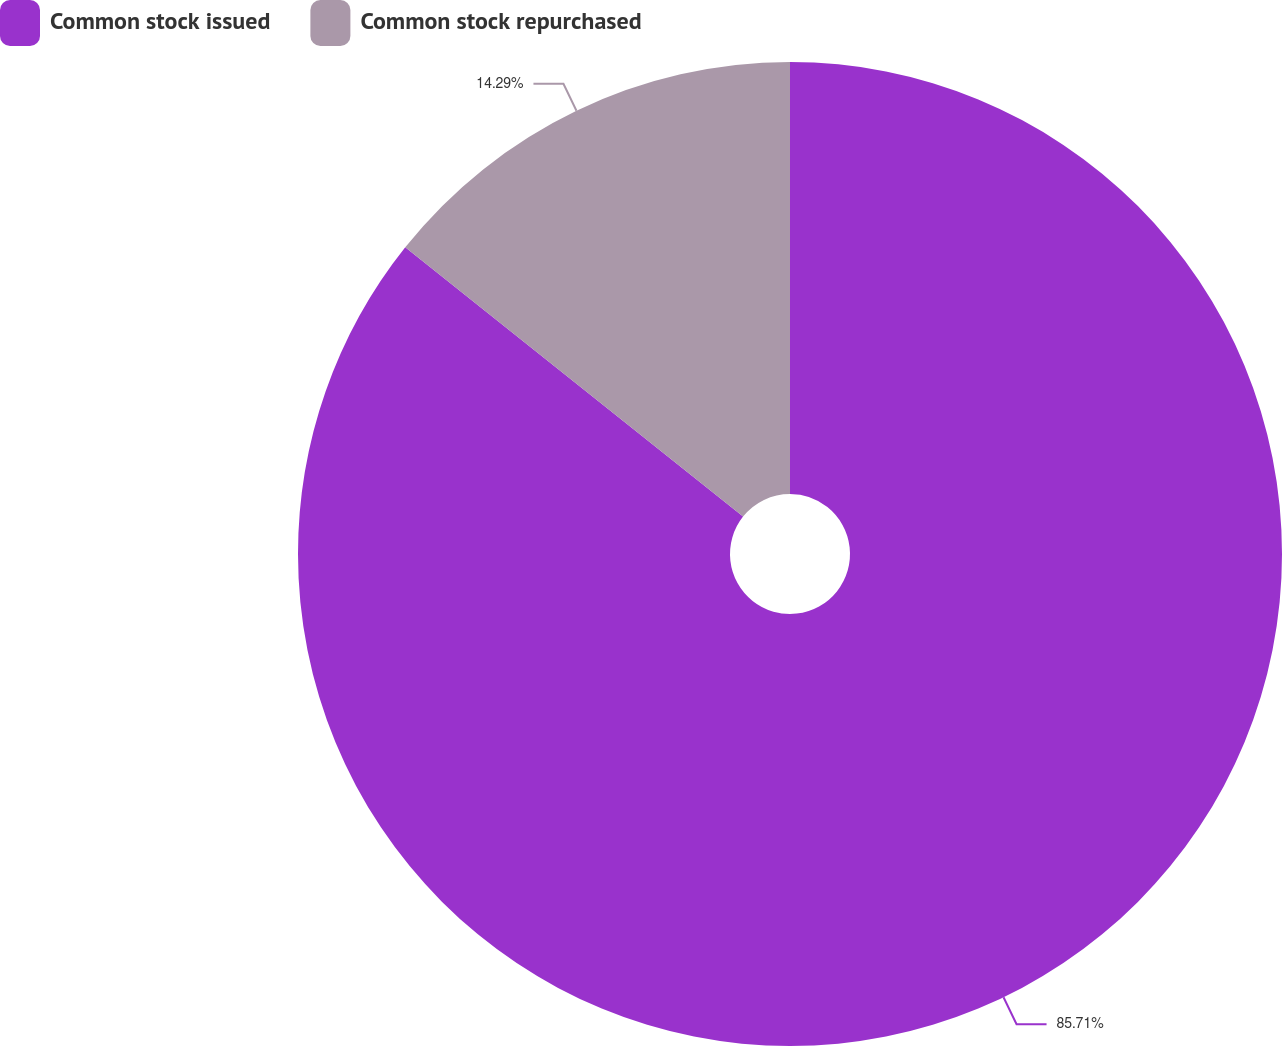Convert chart. <chart><loc_0><loc_0><loc_500><loc_500><pie_chart><fcel>Common stock issued<fcel>Common stock repurchased<nl><fcel>85.71%<fcel>14.29%<nl></chart> 